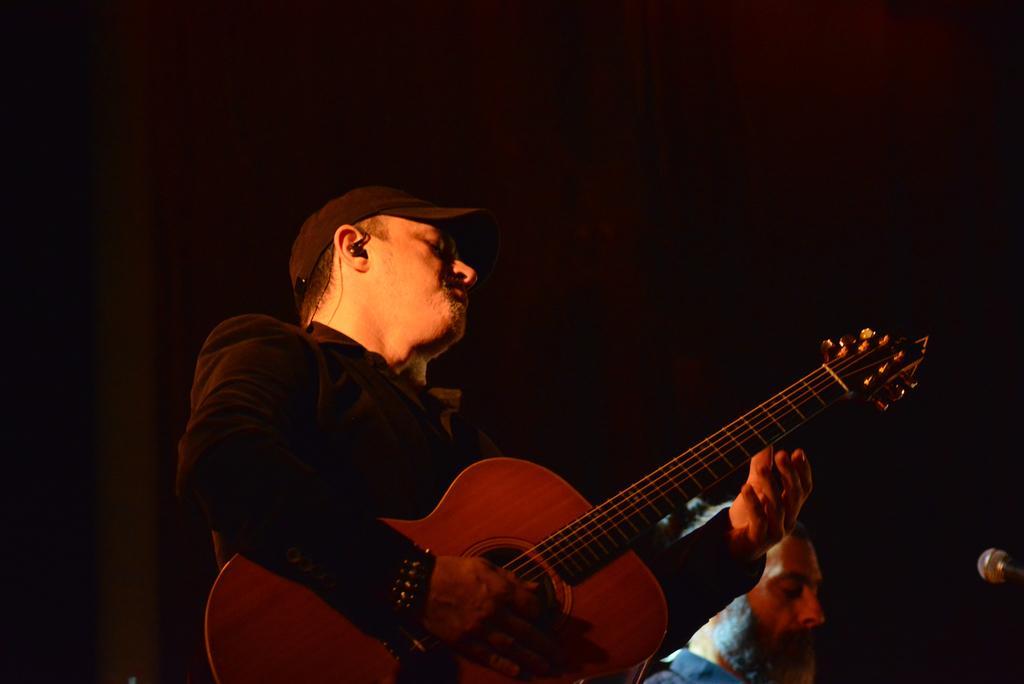Can you describe this image briefly? In this image I can see a person playing guitar and wearing the cap. Beside of him there is another one. In front of them there is a mic. 